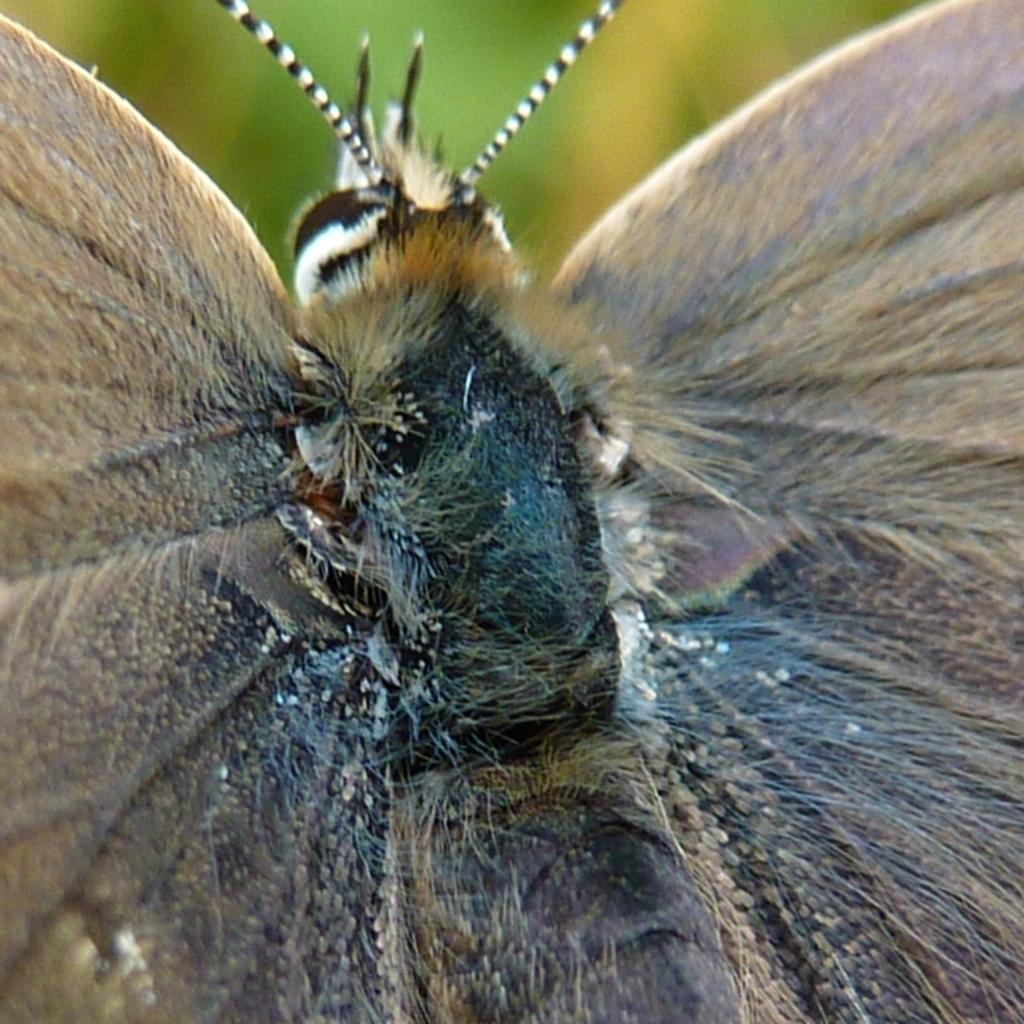Please provide a concise description of this image. In this image I can see an insect which is in black and brown color, and I can see blurred background. 